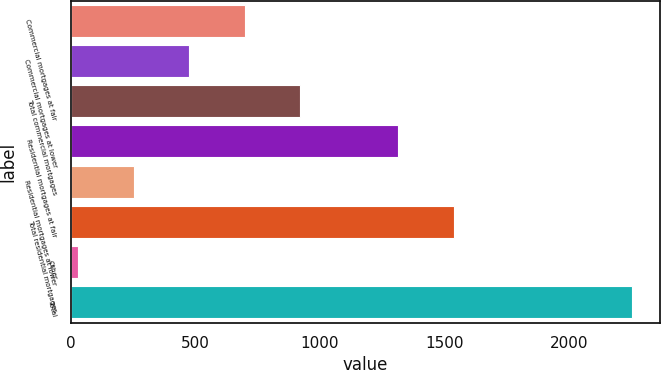Convert chart. <chart><loc_0><loc_0><loc_500><loc_500><bar_chart><fcel>Commercial mortgages at fair<fcel>Commercial mortgages at lower<fcel>Total commercial mortgages<fcel>Residential mortgages at fair<fcel>Residential mortgages at lower<fcel>Total residential mortgages<fcel>Other<fcel>Total<nl><fcel>698.9<fcel>476.6<fcel>921.2<fcel>1315<fcel>254.3<fcel>1537.3<fcel>32<fcel>2255<nl></chart> 